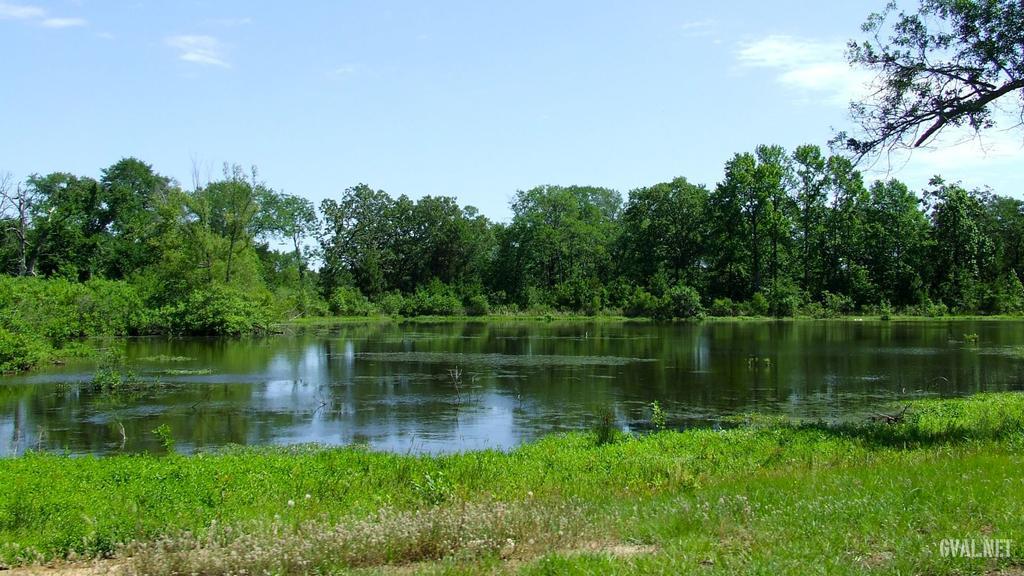Please provide a concise description of this image. In this image in the center there is water. In the front there's grass on the ground. In the background there are trees and the sky is cloudy. 